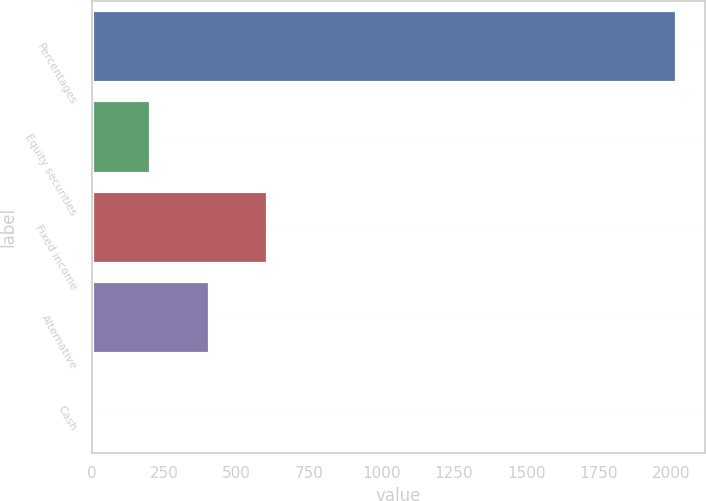<chart> <loc_0><loc_0><loc_500><loc_500><bar_chart><fcel>Percentages<fcel>Equity securities<fcel>Fixed income<fcel>Alternative<fcel>Cash<nl><fcel>2016<fcel>203.4<fcel>606.2<fcel>404.8<fcel>2<nl></chart> 